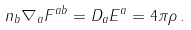<formula> <loc_0><loc_0><loc_500><loc_500>n _ { b } \nabla _ { a } F ^ { a b } = D _ { a } E ^ { a } = 4 \pi \rho \, .</formula> 